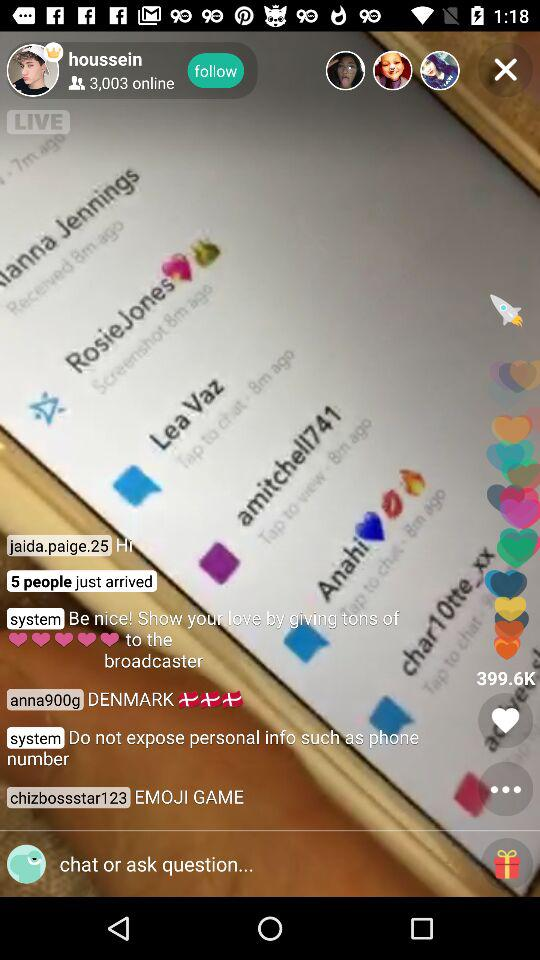What is the username? The usernames are "houssein", "jaida.paige.25", "anna900g" and "chizbossstar123". 